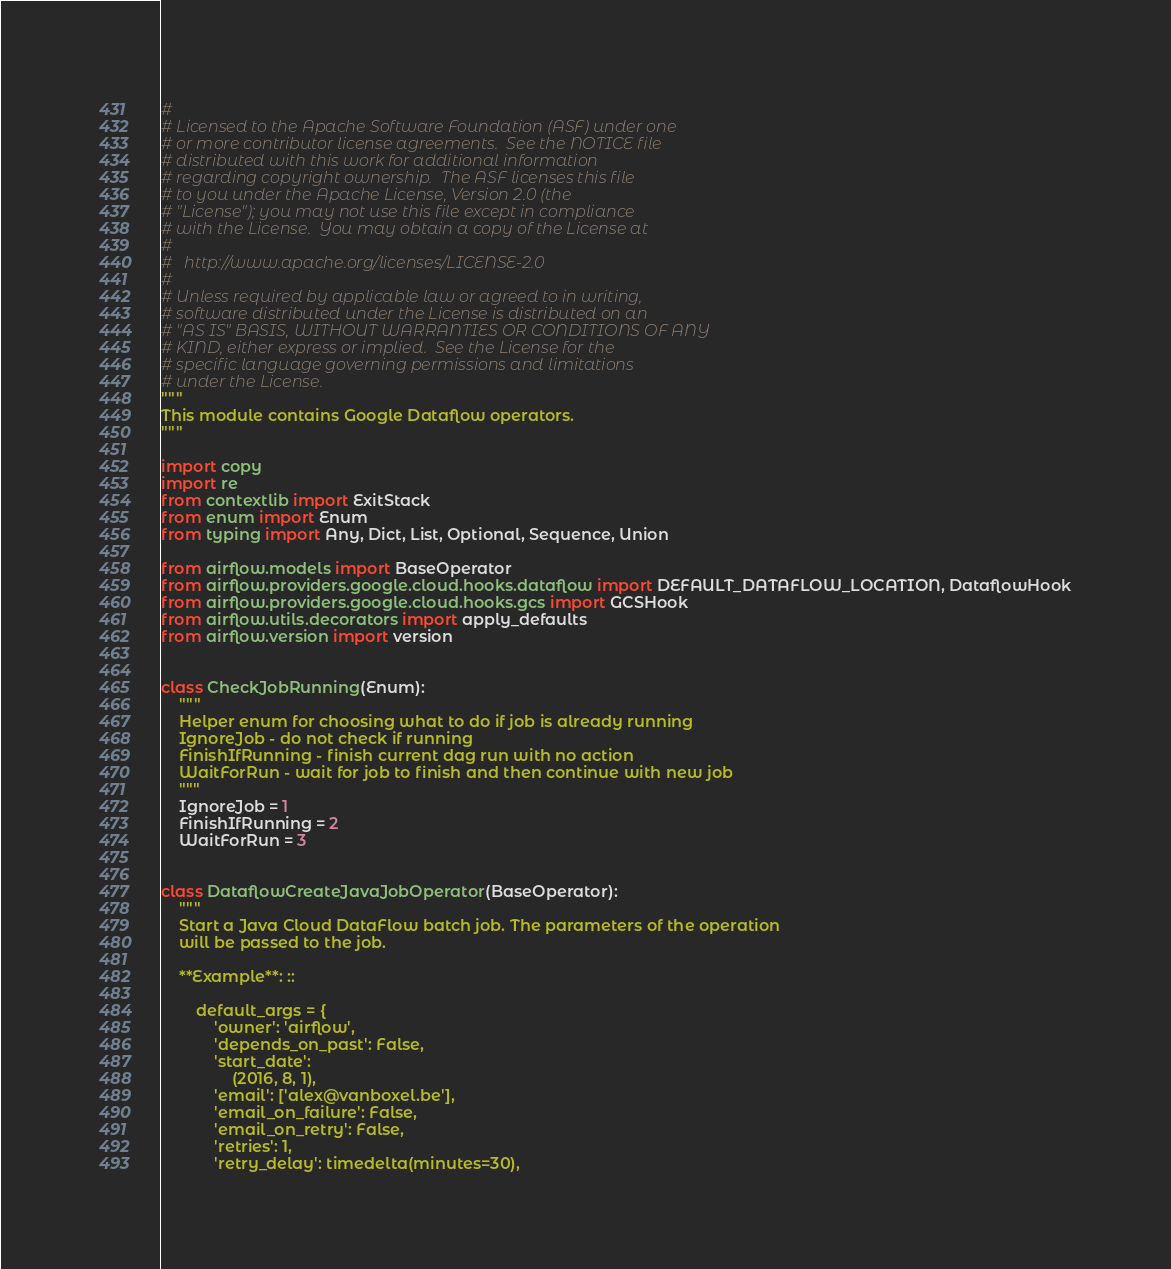<code> <loc_0><loc_0><loc_500><loc_500><_Python_>#
# Licensed to the Apache Software Foundation (ASF) under one
# or more contributor license agreements.  See the NOTICE file
# distributed with this work for additional information
# regarding copyright ownership.  The ASF licenses this file
# to you under the Apache License, Version 2.0 (the
# "License"); you may not use this file except in compliance
# with the License.  You may obtain a copy of the License at
#
#   http://www.apache.org/licenses/LICENSE-2.0
#
# Unless required by applicable law or agreed to in writing,
# software distributed under the License is distributed on an
# "AS IS" BASIS, WITHOUT WARRANTIES OR CONDITIONS OF ANY
# KIND, either express or implied.  See the License for the
# specific language governing permissions and limitations
# under the License.
"""
This module contains Google Dataflow operators.
"""

import copy
import re
from contextlib import ExitStack
from enum import Enum
from typing import Any, Dict, List, Optional, Sequence, Union

from airflow.models import BaseOperator
from airflow.providers.google.cloud.hooks.dataflow import DEFAULT_DATAFLOW_LOCATION, DataflowHook
from airflow.providers.google.cloud.hooks.gcs import GCSHook
from airflow.utils.decorators import apply_defaults
from airflow.version import version


class CheckJobRunning(Enum):
    """
    Helper enum for choosing what to do if job is already running
    IgnoreJob - do not check if running
    FinishIfRunning - finish current dag run with no action
    WaitForRun - wait for job to finish and then continue with new job
    """
    IgnoreJob = 1
    FinishIfRunning = 2
    WaitForRun = 3


class DataflowCreateJavaJobOperator(BaseOperator):
    """
    Start a Java Cloud DataFlow batch job. The parameters of the operation
    will be passed to the job.

    **Example**: ::

        default_args = {
            'owner': 'airflow',
            'depends_on_past': False,
            'start_date':
                (2016, 8, 1),
            'email': ['alex@vanboxel.be'],
            'email_on_failure': False,
            'email_on_retry': False,
            'retries': 1,
            'retry_delay': timedelta(minutes=30),</code> 